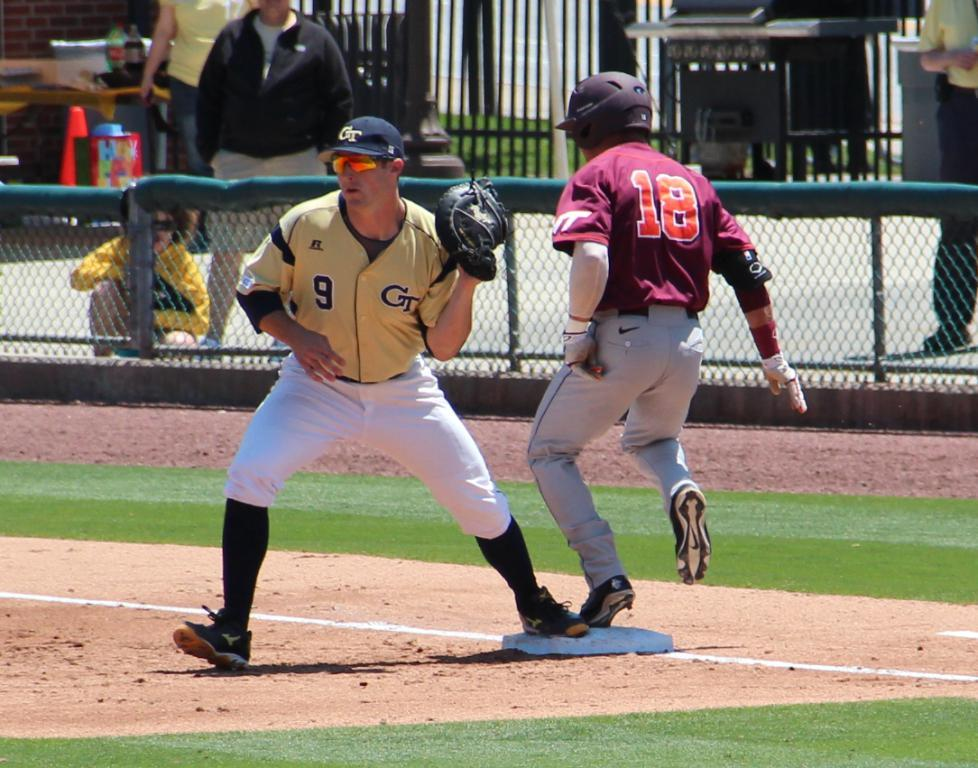<image>
Render a clear and concise summary of the photo. Player number 18 has just stepped on to the base in this ball game. 